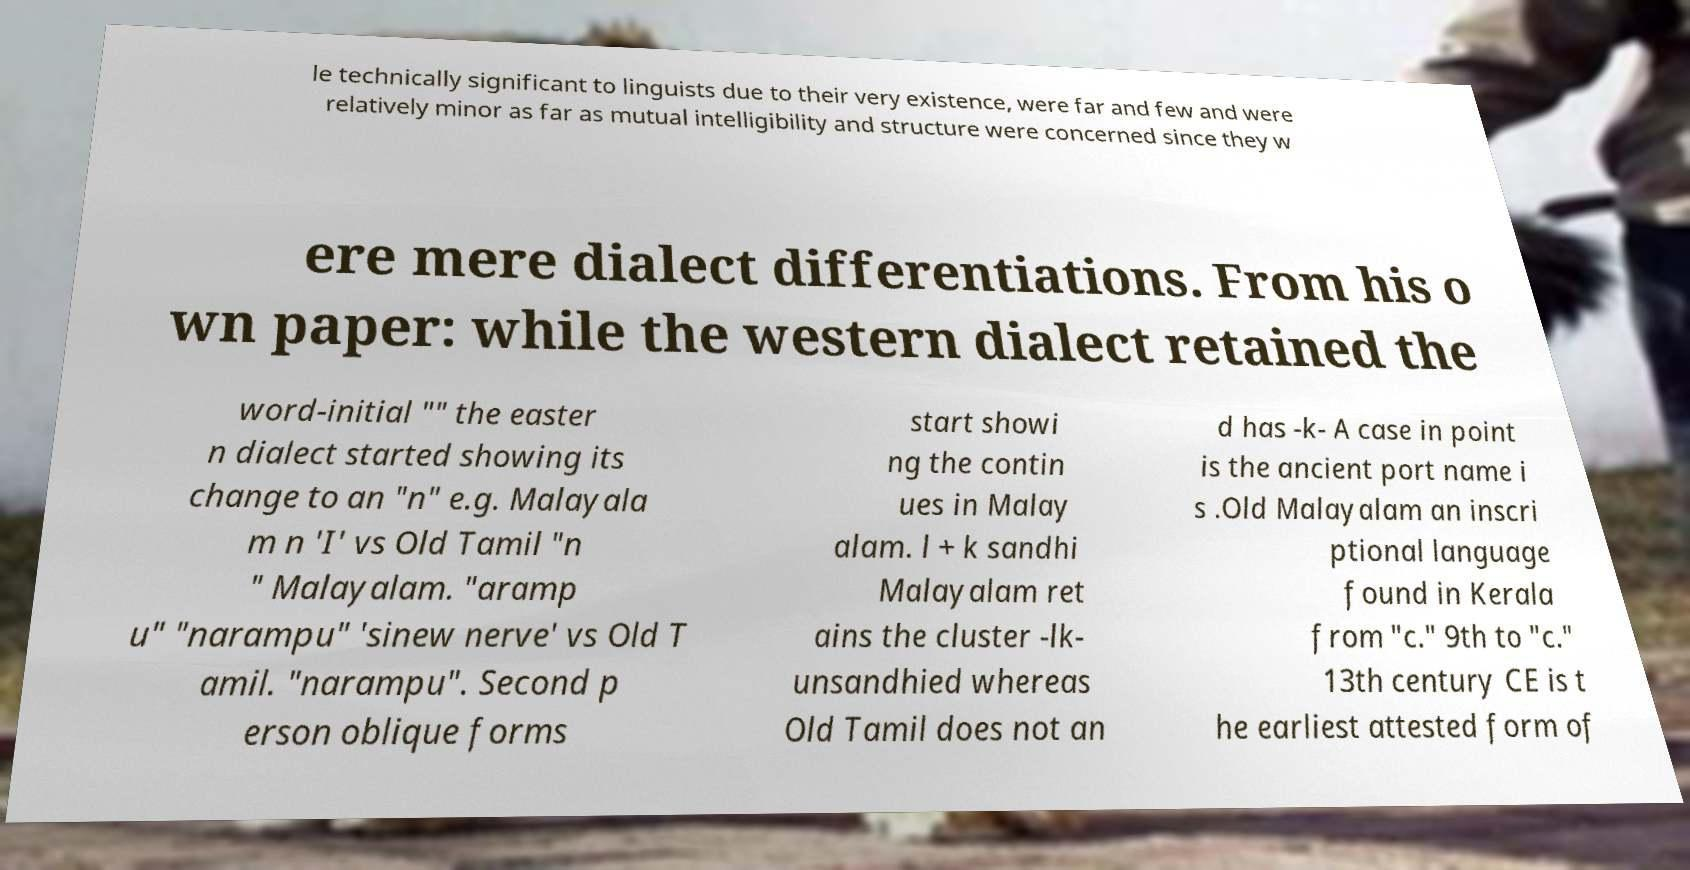Please identify and transcribe the text found in this image. le technically significant to linguists due to their very existence, were far and few and were relatively minor as far as mutual intelligibility and structure were concerned since they w ere mere dialect differentiations. From his o wn paper: while the western dialect retained the word-initial "" the easter n dialect started showing its change to an "n" e.g. Malayala m n 'I' vs Old Tamil "n " Malayalam. "aramp u" "narampu" 'sinew nerve' vs Old T amil. "narampu". Second p erson oblique forms start showi ng the contin ues in Malay alam. l + k sandhi Malayalam ret ains the cluster -lk- unsandhied whereas Old Tamil does not an d has -k- A case in point is the ancient port name i s .Old Malayalam an inscri ptional language found in Kerala from "c." 9th to "c." 13th century CE is t he earliest attested form of 